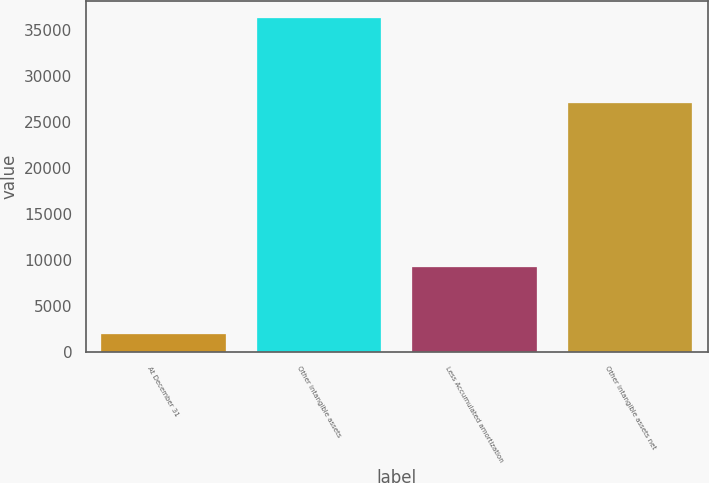Convert chart. <chart><loc_0><loc_0><loc_500><loc_500><bar_chart><fcel>At December 31<fcel>Other intangible assets<fcel>Less Accumulated amortization<fcel>Other intangible assets net<nl><fcel>2013<fcel>36352<fcel>9240<fcel>27112<nl></chart> 